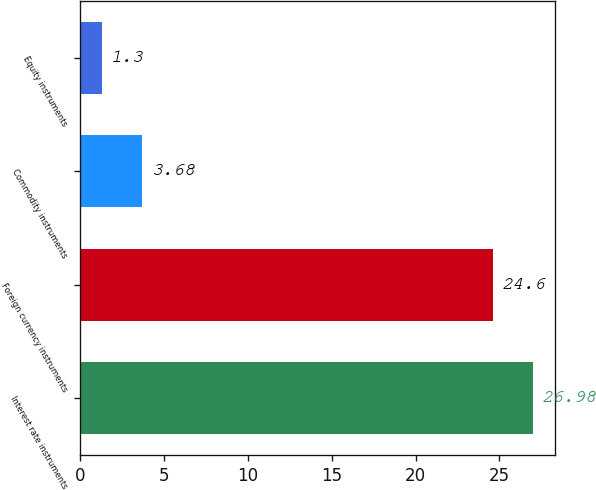<chart> <loc_0><loc_0><loc_500><loc_500><bar_chart><fcel>Interest rate instruments<fcel>Foreign currency instruments<fcel>Commodity instruments<fcel>Equity instruments<nl><fcel>26.98<fcel>24.6<fcel>3.68<fcel>1.3<nl></chart> 